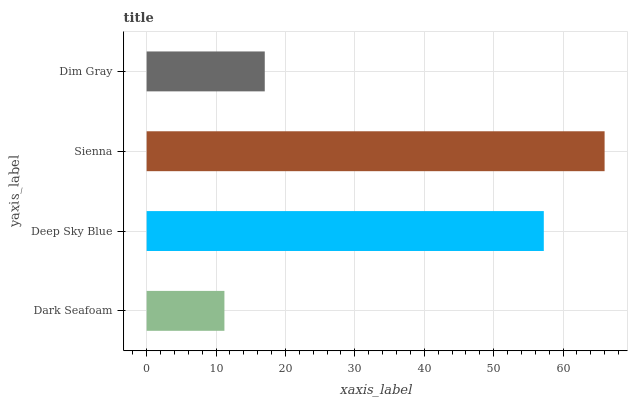Is Dark Seafoam the minimum?
Answer yes or no. Yes. Is Sienna the maximum?
Answer yes or no. Yes. Is Deep Sky Blue the minimum?
Answer yes or no. No. Is Deep Sky Blue the maximum?
Answer yes or no. No. Is Deep Sky Blue greater than Dark Seafoam?
Answer yes or no. Yes. Is Dark Seafoam less than Deep Sky Blue?
Answer yes or no. Yes. Is Dark Seafoam greater than Deep Sky Blue?
Answer yes or no. No. Is Deep Sky Blue less than Dark Seafoam?
Answer yes or no. No. Is Deep Sky Blue the high median?
Answer yes or no. Yes. Is Dim Gray the low median?
Answer yes or no. Yes. Is Dark Seafoam the high median?
Answer yes or no. No. Is Dark Seafoam the low median?
Answer yes or no. No. 